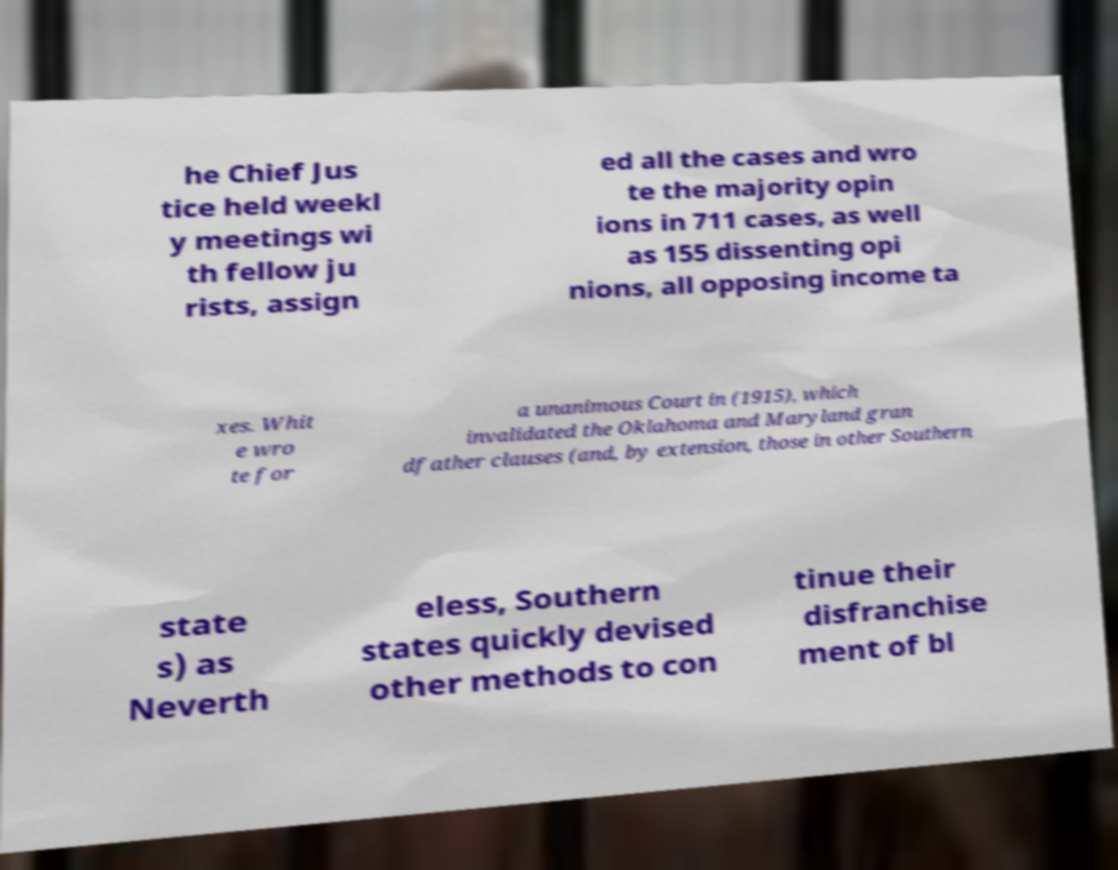Could you assist in decoding the text presented in this image and type it out clearly? he Chief Jus tice held weekl y meetings wi th fellow ju rists, assign ed all the cases and wro te the majority opin ions in 711 cases, as well as 155 dissenting opi nions, all opposing income ta xes. Whit e wro te for a unanimous Court in (1915), which invalidated the Oklahoma and Maryland gran dfather clauses (and, by extension, those in other Southern state s) as Neverth eless, Southern states quickly devised other methods to con tinue their disfranchise ment of bl 